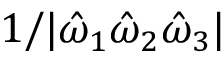Convert formula to latex. <formula><loc_0><loc_0><loc_500><loc_500>1 / | \hat { \omega } _ { 1 } \hat { \omega } _ { 2 } \hat { \omega } _ { 3 } |</formula> 